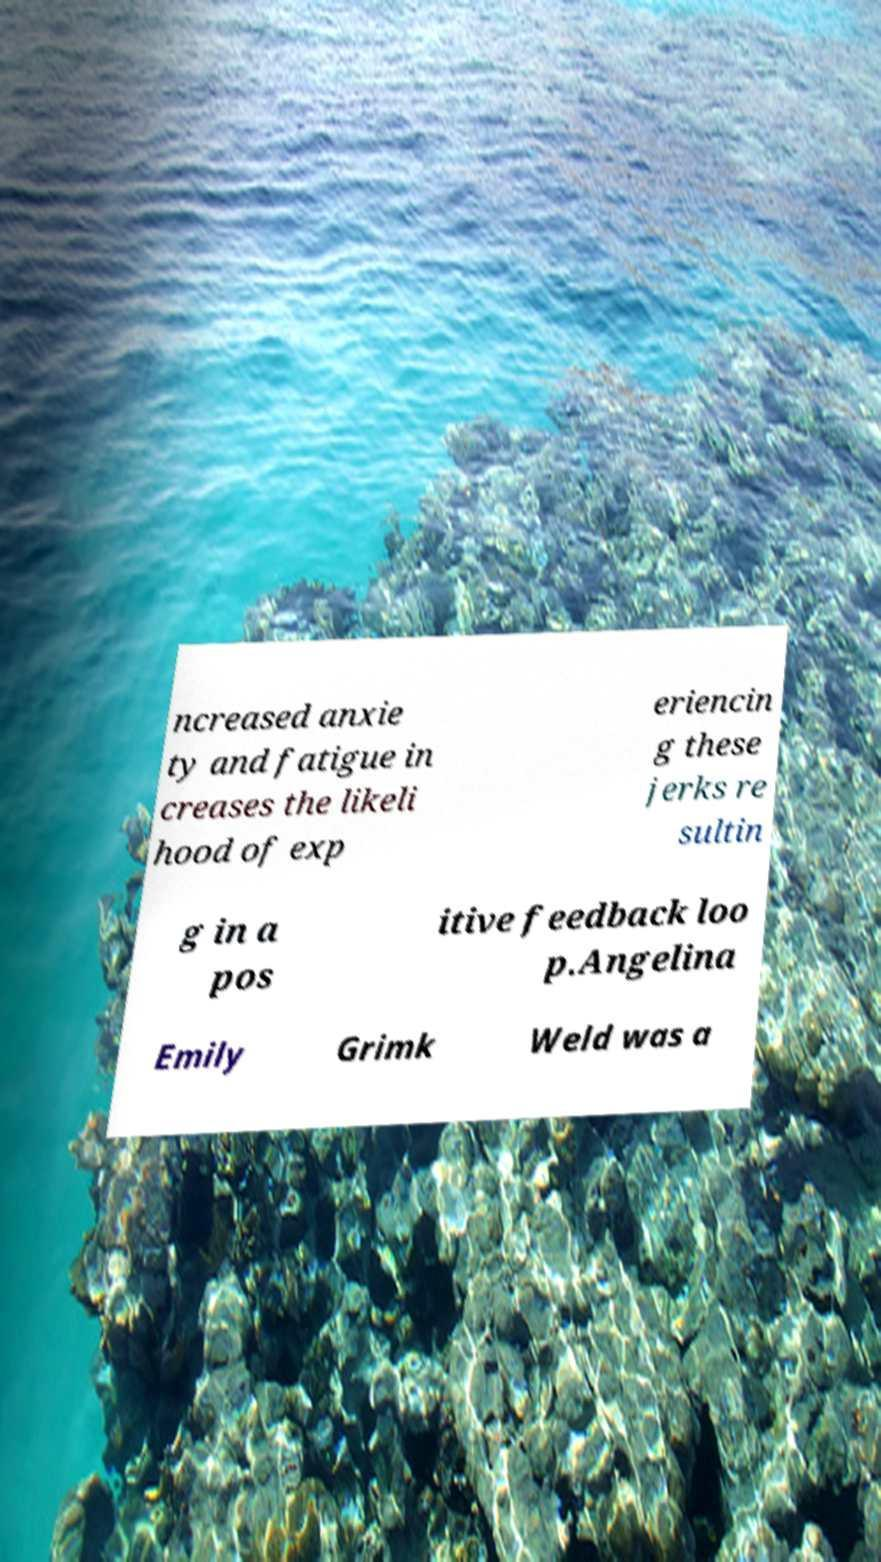Can you accurately transcribe the text from the provided image for me? ncreased anxie ty and fatigue in creases the likeli hood of exp eriencin g these jerks re sultin g in a pos itive feedback loo p.Angelina Emily Grimk Weld was a 